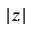<formula> <loc_0><loc_0><loc_500><loc_500>| z |</formula> 